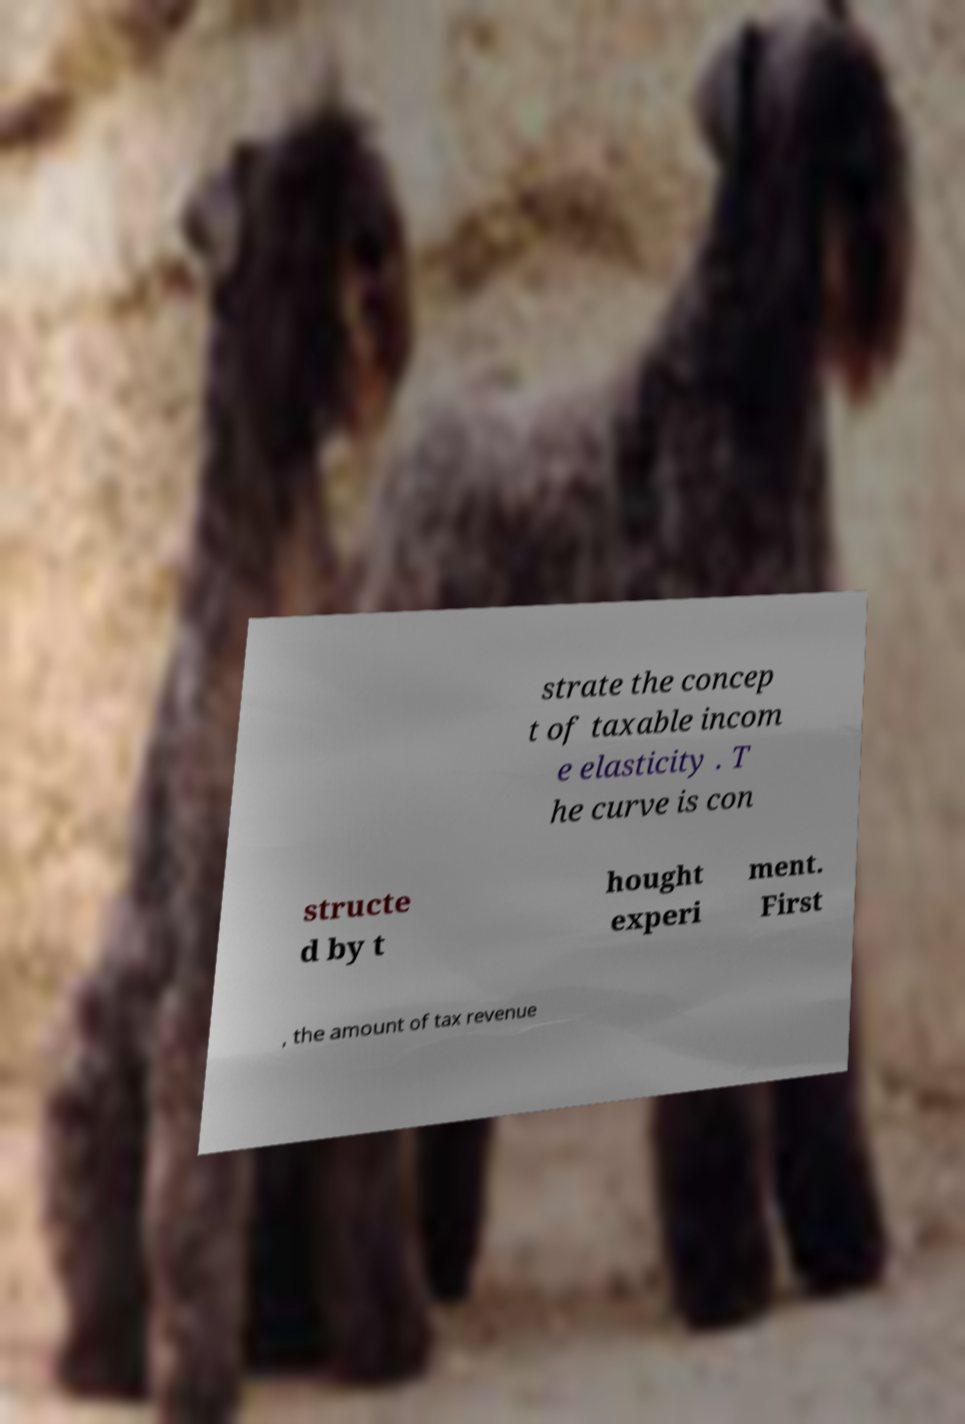Please identify and transcribe the text found in this image. strate the concep t of taxable incom e elasticity . T he curve is con structe d by t hought experi ment. First , the amount of tax revenue 